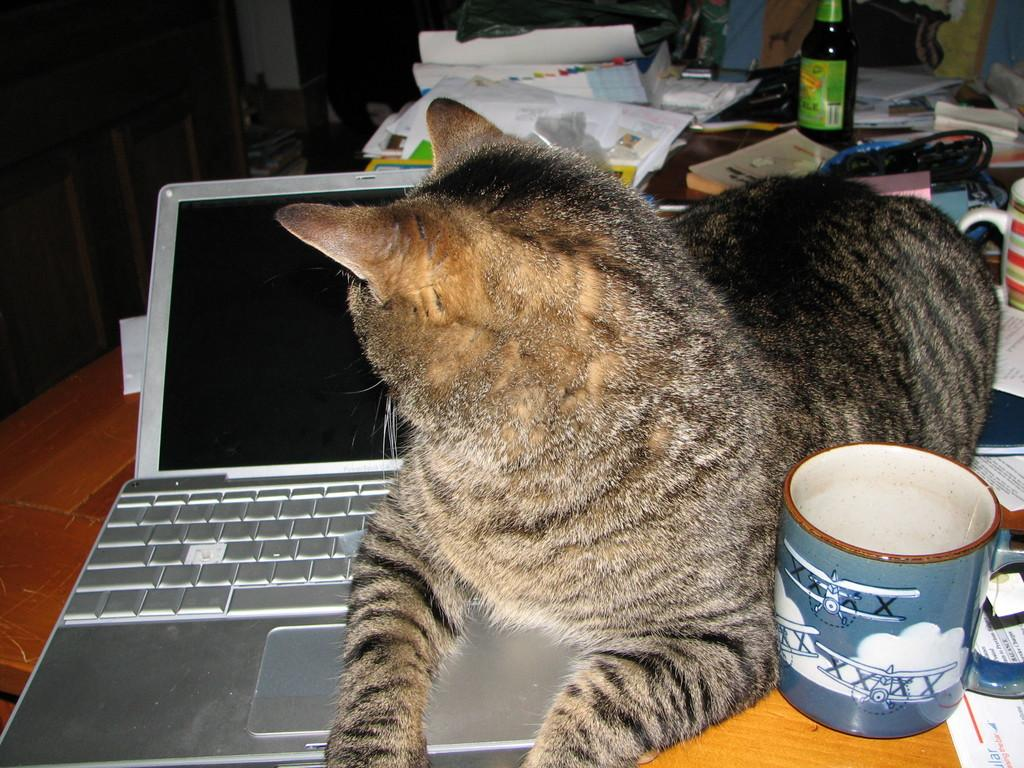What type of objects can be seen in the image? There are books, a bottle, a jar, a laptop, papers, and a cat in the image. What is the surface that most of these objects are placed on? There is a wooden table in the image. What part of the image is dark? The top left corner of the image is dark. What type of food is the cat eating in the image? There is no food present in the image, and the cat is not shown eating anything. Is there a veil covering any of the objects in the image? No, there is no veil present in the image. Can you see a robin perched on any of the objects in the image? No, there is no robin present in the image. 